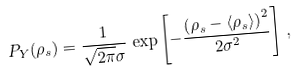<formula> <loc_0><loc_0><loc_500><loc_500>P _ { Y } ( \rho _ { s } ) = \frac { 1 } { \sqrt { 2 \pi } \sigma } \, \exp \left [ - \frac { \left ( \rho _ { s } - \langle \rho _ { s } \rangle \right ) ^ { 2 } } { 2 \sigma ^ { 2 } } \right ] \, ,</formula> 